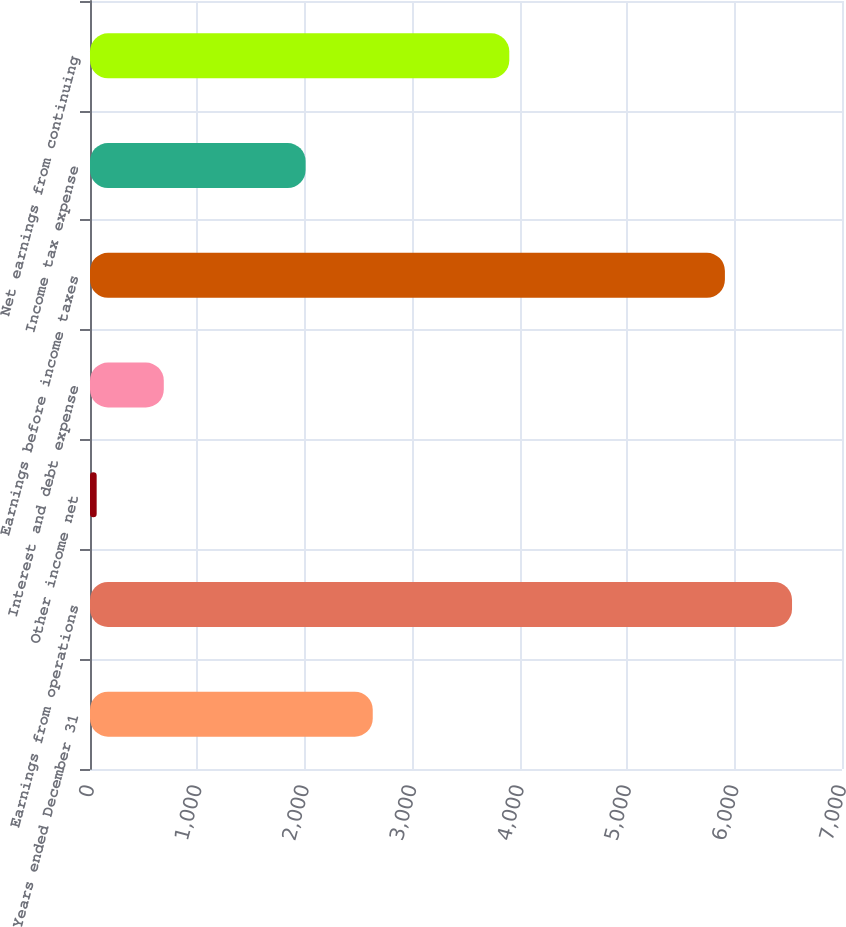<chart> <loc_0><loc_0><loc_500><loc_500><bar_chart><fcel>Years ended December 31<fcel>Earnings from operations<fcel>Other income net<fcel>Interest and debt expense<fcel>Earnings before income taxes<fcel>Income tax expense<fcel>Net earnings from continuing<nl><fcel>2631.9<fcel>6534.9<fcel>62<fcel>686.9<fcel>5910<fcel>2007<fcel>3903<nl></chart> 